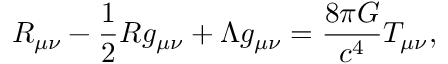Convert formula to latex. <formula><loc_0><loc_0><loc_500><loc_500>R _ { \mu \nu } - { \frac { 1 } { 2 } } R g _ { \mu \nu } + \Lambda g _ { \mu \nu } = { \frac { 8 \pi G } { c ^ { 4 } } } T _ { \mu \nu } ,</formula> 